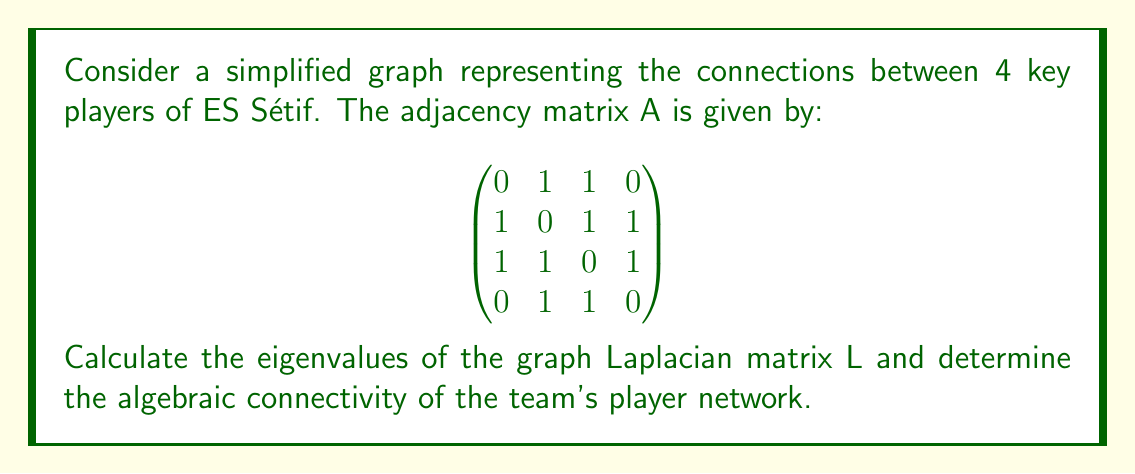Can you solve this math problem? 1) First, we need to calculate the graph Laplacian matrix L. The formula is L = D - A, where D is the degree matrix and A is the adjacency matrix.

2) Calculate the degree matrix D:
   $$D = \begin{bmatrix}
   2 & 0 & 0 & 0 \\
   0 & 3 & 0 & 0 \\
   0 & 0 & 3 & 0 \\
   0 & 0 & 0 & 2
   \end{bmatrix}$$

3) Calculate L = D - A:
   $$L = \begin{bmatrix}
   2 & -1 & -1 & 0 \\
   -1 & 3 & -1 & -1 \\
   -1 & -1 & 3 & -1 \\
   0 & -1 & -1 & 2
   \end{bmatrix}$$

4) To find the eigenvalues, we need to solve the characteristic equation det(L - λI) = 0.

5) Expanding the determinant:
   $$(2-λ)(3-λ)^2(2-λ) - (2-λ)(3-λ) - (3-λ)(2-λ) - (3-λ)^2 = 0$$

6) Simplifying:
   $$λ^4 - 10λ^3 + 31λ^2 - 30λ = 0$$

7) Factoring:
   $$λ(λ^3 - 10λ^2 + 31λ - 30) = 0$$
   $$λ(λ - 1)(λ - 4)(λ - 5) = 0$$

8) The eigenvalues are: λ₁ = 0, λ₂ = 1, λ₃ = 4, λ₄ = 5

9) The algebraic connectivity is the second smallest eigenvalue, which is λ₂ = 1.
Answer: Eigenvalues: 0, 1, 4, 5; Algebraic connectivity: 1 